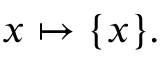Convert formula to latex. <formula><loc_0><loc_0><loc_500><loc_500>x \mapsto \{ x \} .</formula> 